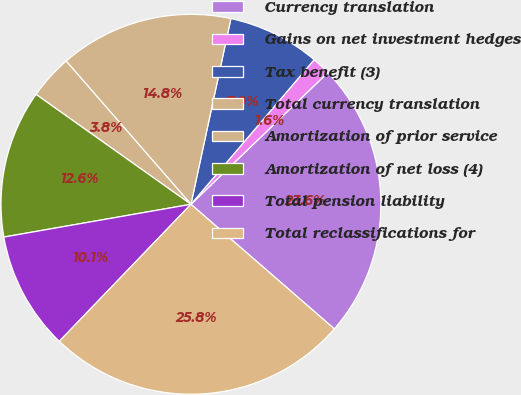Convert chart to OTSL. <chart><loc_0><loc_0><loc_500><loc_500><pie_chart><fcel>Currency translation<fcel>Gains on net investment hedges<fcel>Tax benefit (3)<fcel>Total currency translation<fcel>Amortization of prior service<fcel>Amortization of net loss (4)<fcel>Total pension liability<fcel>Total reclassifications for<nl><fcel>23.58%<fcel>1.57%<fcel>7.86%<fcel>14.78%<fcel>3.77%<fcel>12.58%<fcel>10.06%<fcel>25.79%<nl></chart> 